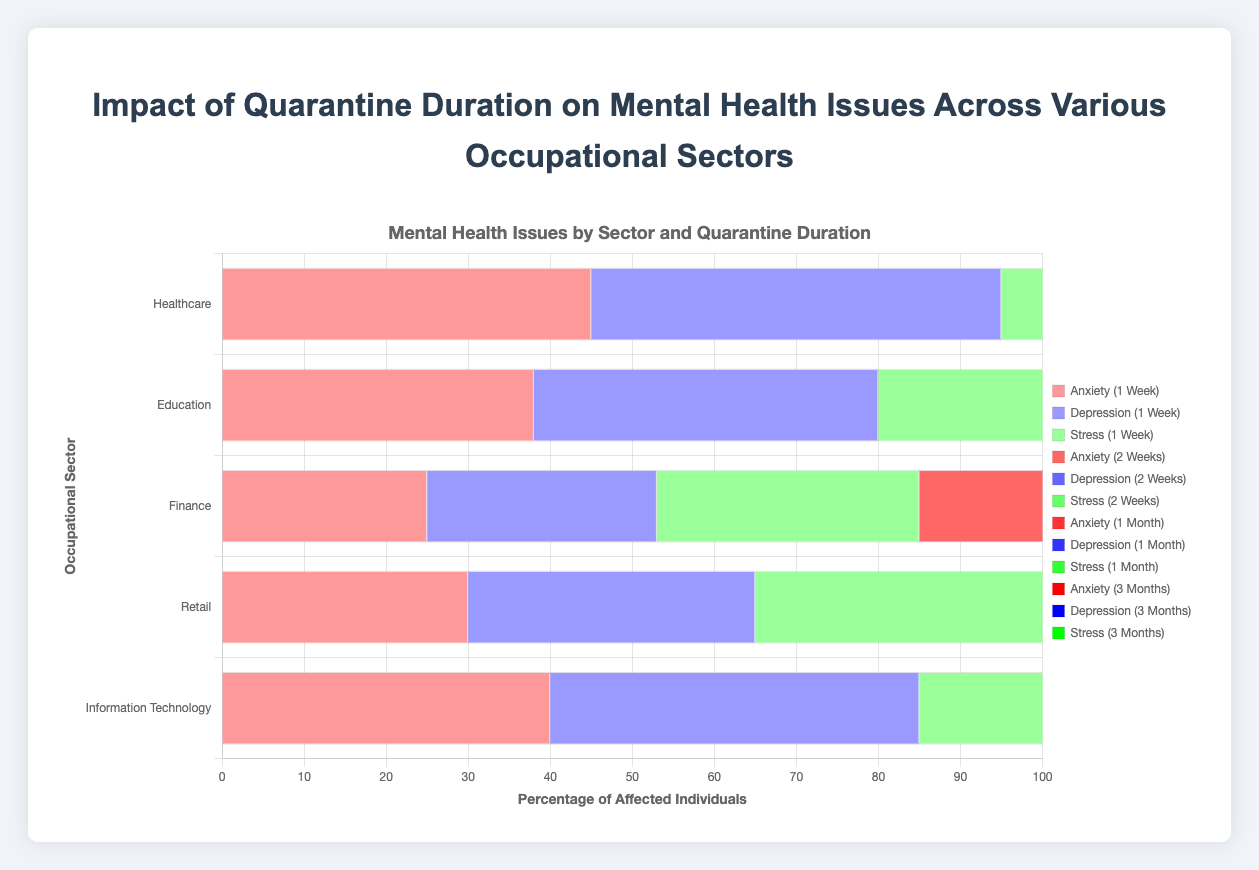What sector has the highest levels of anxiety after 3 months of quarantine? From the chart, observe the bars for anxiety after 3 months of quarantine across different sectors. The sector with the longest bar represents the highest level. In this case, Healthcare has the highest level with a value of 90.
Answer: Healthcare Which occupational sector shows the least increase in depression levels from 1 week to 1 month of quarantine? To answer this, subtract the 1-week values from the 1-month values for depression for each sector and find the smallest difference. The values are: Healthcare (80-50=30), Education (70-42=28), Finance (48-28=20), Retail (65-35=30), Information Technology (75-45=30). The smallest increase is in the financial sector, with a difference of 20.
Answer: Finance What is the average stress level for the education sector across all quarantine durations? Sum the stress values for the education sector across all durations and divide by the number of durations: (48 + 60 + 75 + 90) / 4 = 273 / 4 = 68.25.
Answer: 68.25 In which sector is the impact of quarantine on anxiety levels more than depression and stress levels for all durations? Compare anxiety, depression, and stress bars for each sector. Check if the anxiety bars are always higher than the other two issues across all durations. This pattern is observable in the Education sector.
Answer: Education Which mental health issue shows the highest percentage affected in the Information Technology sector after 1 month of quarantine? Look at the 1-month quarantine group for Information Technology and compare the values for anxiety, depression, and stress. Anxiety has 70, depression has 75, and stress has 80. Stress shows the highest percentage.
Answer: Stress How much does the stress level in retail increase from 1 week to 3 months of quarantine? Subtract the 1-week stress value for Retail from the 3-months value: (85 - 40) = 45.
Answer: 45 Which occupational sector has the least difference between anxiety and depression levels after 2 weeks of quarantine? Calculate the difference between anxiety and depression levels for all sectors after 2 weeks: Healthcare (65-60=5), Education (55-50=5), Finance (38-35=3), Retail (50-45=5), Information Technology (58-55=3). The least difference is in Finance and IT, both having a difference of 3.
Answer: Finance, Information Technology What is the overall increase in depression levels in the Healthcare sector from 1 week to 3 months of quarantine? Subtract the 1-week values from the 3-month values for depression in Healthcare: 95 - 50 = 45.
Answer: 45 